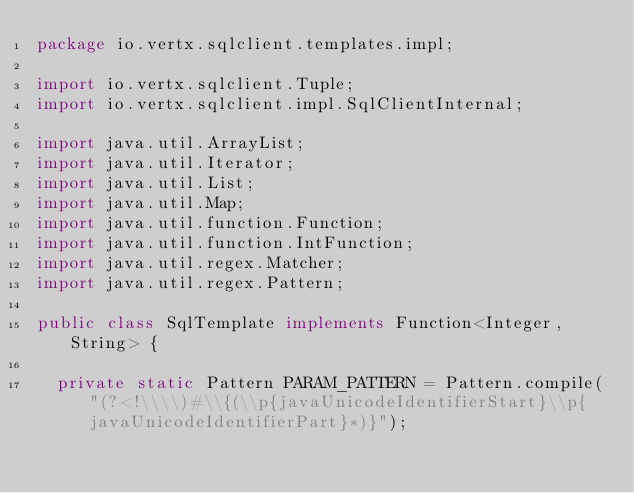<code> <loc_0><loc_0><loc_500><loc_500><_Java_>package io.vertx.sqlclient.templates.impl;

import io.vertx.sqlclient.Tuple;
import io.vertx.sqlclient.impl.SqlClientInternal;

import java.util.ArrayList;
import java.util.Iterator;
import java.util.List;
import java.util.Map;
import java.util.function.Function;
import java.util.function.IntFunction;
import java.util.regex.Matcher;
import java.util.regex.Pattern;

public class SqlTemplate implements Function<Integer, String> {

  private static Pattern PARAM_PATTERN = Pattern.compile("(?<!\\\\)#\\{(\\p{javaUnicodeIdentifierStart}\\p{javaUnicodeIdentifierPart}*)}");</code> 